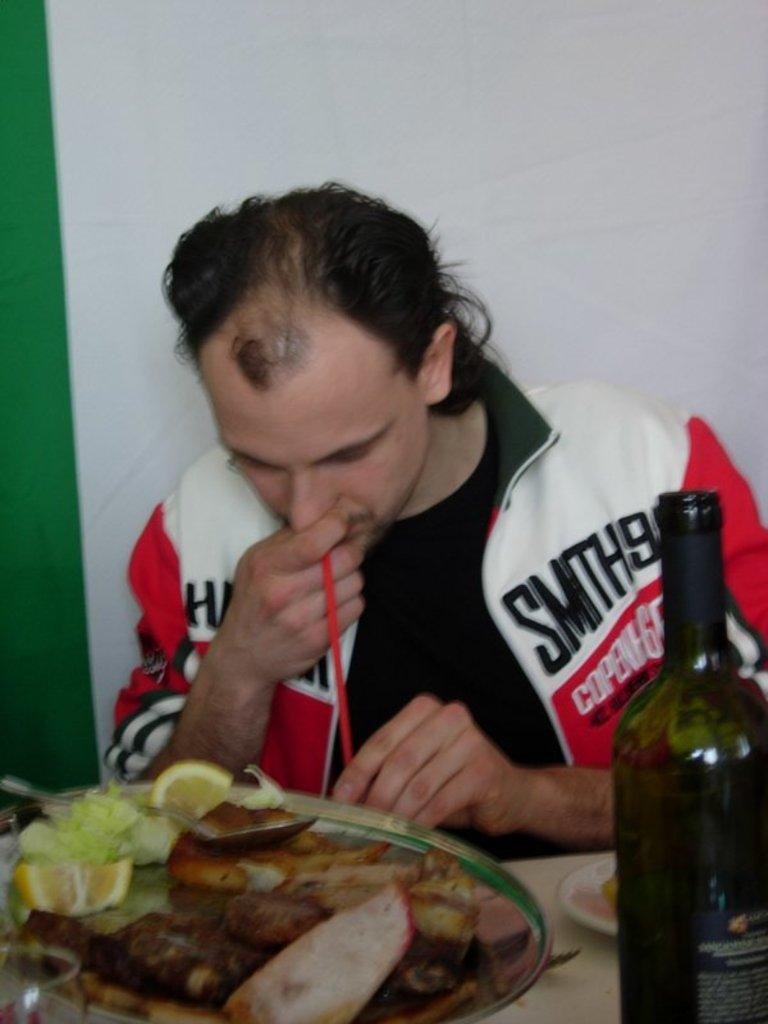What is the person in the image doing? The person is sitting in the image. Where is the person sitting in relation to the table? The person is sitting in front of a table. What can be found on the table in the image? There are eatables on the table. Is there a cracker flying through the air in the image? There is no cracker present in the image, let alone one flying through the air. 